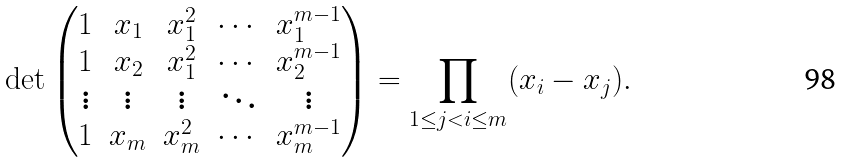<formula> <loc_0><loc_0><loc_500><loc_500>\det \begin{pmatrix} 1 & x _ { 1 } & x _ { 1 } ^ { 2 } & \cdots & x _ { 1 } ^ { m - 1 } \\ 1 & x _ { 2 } & x _ { 1 } ^ { 2 } & \cdots & x _ { 2 } ^ { m - 1 } \\ \vdots & \vdots & \vdots & \ddots & \vdots \\ 1 & x _ { m } & x _ { m } ^ { 2 } & \cdots & x _ { m } ^ { m - 1 } \end{pmatrix} = \prod _ { 1 \leq j < i \leq m } ( x _ { i } - x _ { j } ) .</formula> 